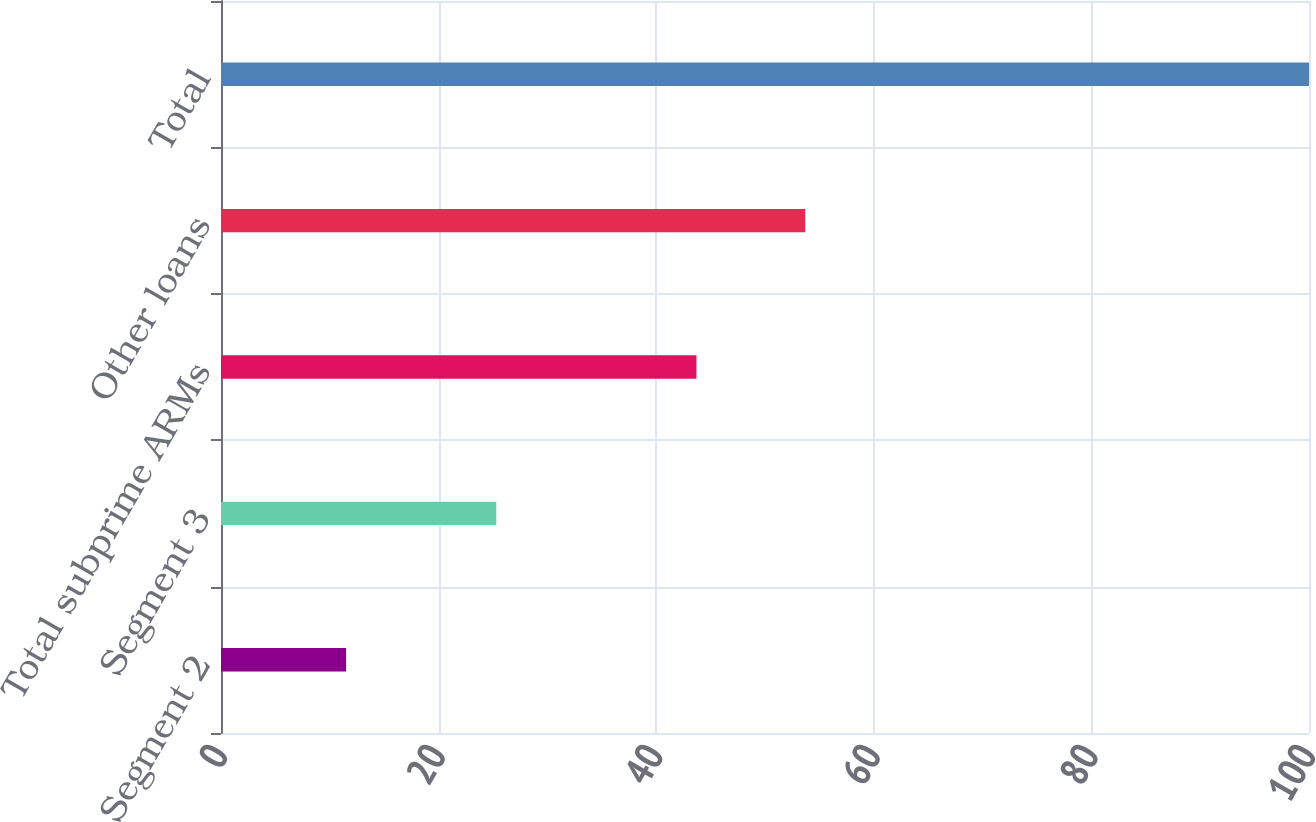Convert chart. <chart><loc_0><loc_0><loc_500><loc_500><bar_chart><fcel>Segment 2<fcel>Segment 3<fcel>Total subprime ARMs<fcel>Other loans<fcel>Total<nl><fcel>11.5<fcel>25.3<fcel>43.7<fcel>53.7<fcel>100<nl></chart> 